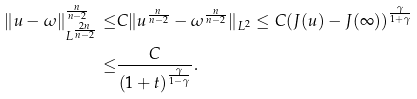<formula> <loc_0><loc_0><loc_500><loc_500>\| u - \omega \| _ { L ^ { \frac { 2 n } { n - 2 } } } ^ { \frac { n } { n - 2 } } \leq & C \| u ^ { \frac { n } { n - 2 } } - \omega ^ { \frac { n } { n - 2 } } \| _ { L ^ { 2 } } \leq C ( J ( u ) - J ( \infty ) ) ^ { \frac { \gamma } { 1 + \gamma } } \\ \leq & \frac { C } { ( 1 + t ) ^ { \frac { \gamma } { 1 - \gamma } } } .</formula> 